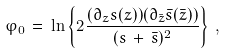Convert formula to latex. <formula><loc_0><loc_0><loc_500><loc_500>\varphi _ { 0 } \, = \, \ln \left \{ 2 \frac { ( \partial _ { z } s ( z ) ) ( \partial _ { \bar { z } } \bar { s } ( \bar { z } ) ) } { ( s \, + \, \bar { s } ) ^ { 2 } } \right \} \, ,</formula> 